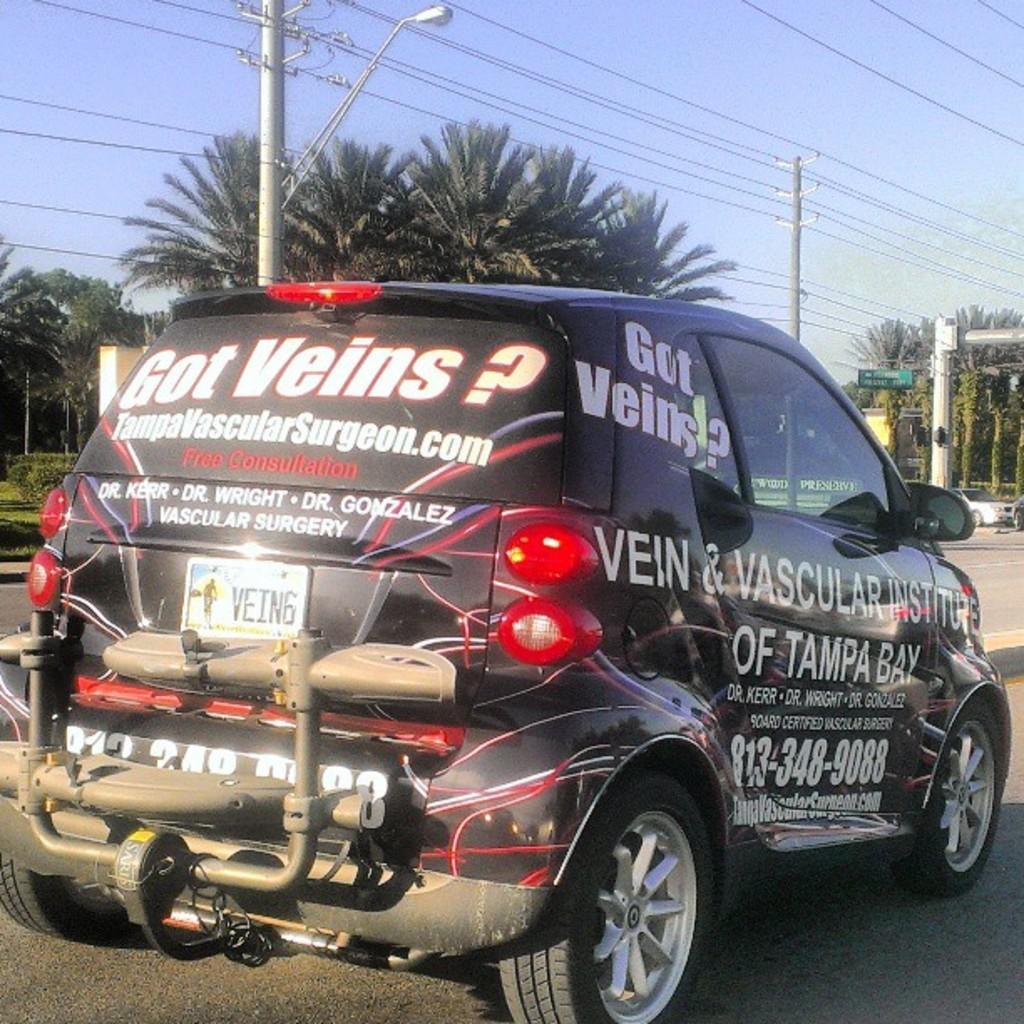In one or two sentences, can you explain what this image depicts? In this picture there is a black color car with many quotes written on it is moving on the road. Behind there is a coconut trees and electric pole with many cables. 